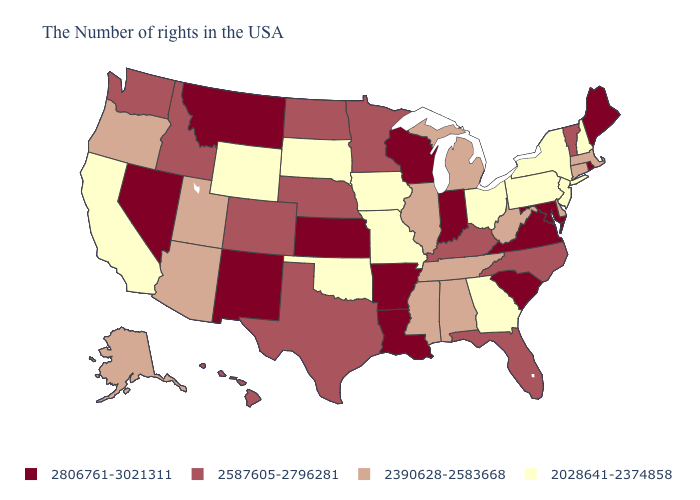Among the states that border Illinois , does Wisconsin have the lowest value?
Answer briefly. No. Among the states that border Wyoming , does Montana have the highest value?
Quick response, please. Yes. Among the states that border New Hampshire , which have the lowest value?
Answer briefly. Massachusetts. Name the states that have a value in the range 2390628-2583668?
Keep it brief. Massachusetts, Connecticut, Delaware, West Virginia, Michigan, Alabama, Tennessee, Illinois, Mississippi, Utah, Arizona, Oregon, Alaska. What is the value of West Virginia?
Be succinct. 2390628-2583668. What is the value of Kansas?
Concise answer only. 2806761-3021311. Name the states that have a value in the range 2390628-2583668?
Short answer required. Massachusetts, Connecticut, Delaware, West Virginia, Michigan, Alabama, Tennessee, Illinois, Mississippi, Utah, Arizona, Oregon, Alaska. Does New Hampshire have the lowest value in the Northeast?
Give a very brief answer. Yes. Is the legend a continuous bar?
Short answer required. No. Does Texas have the highest value in the South?
Keep it brief. No. Does Mississippi have the same value as West Virginia?
Be succinct. Yes. Which states hav the highest value in the Northeast?
Short answer required. Maine, Rhode Island. Does Florida have the lowest value in the South?
Be succinct. No. 